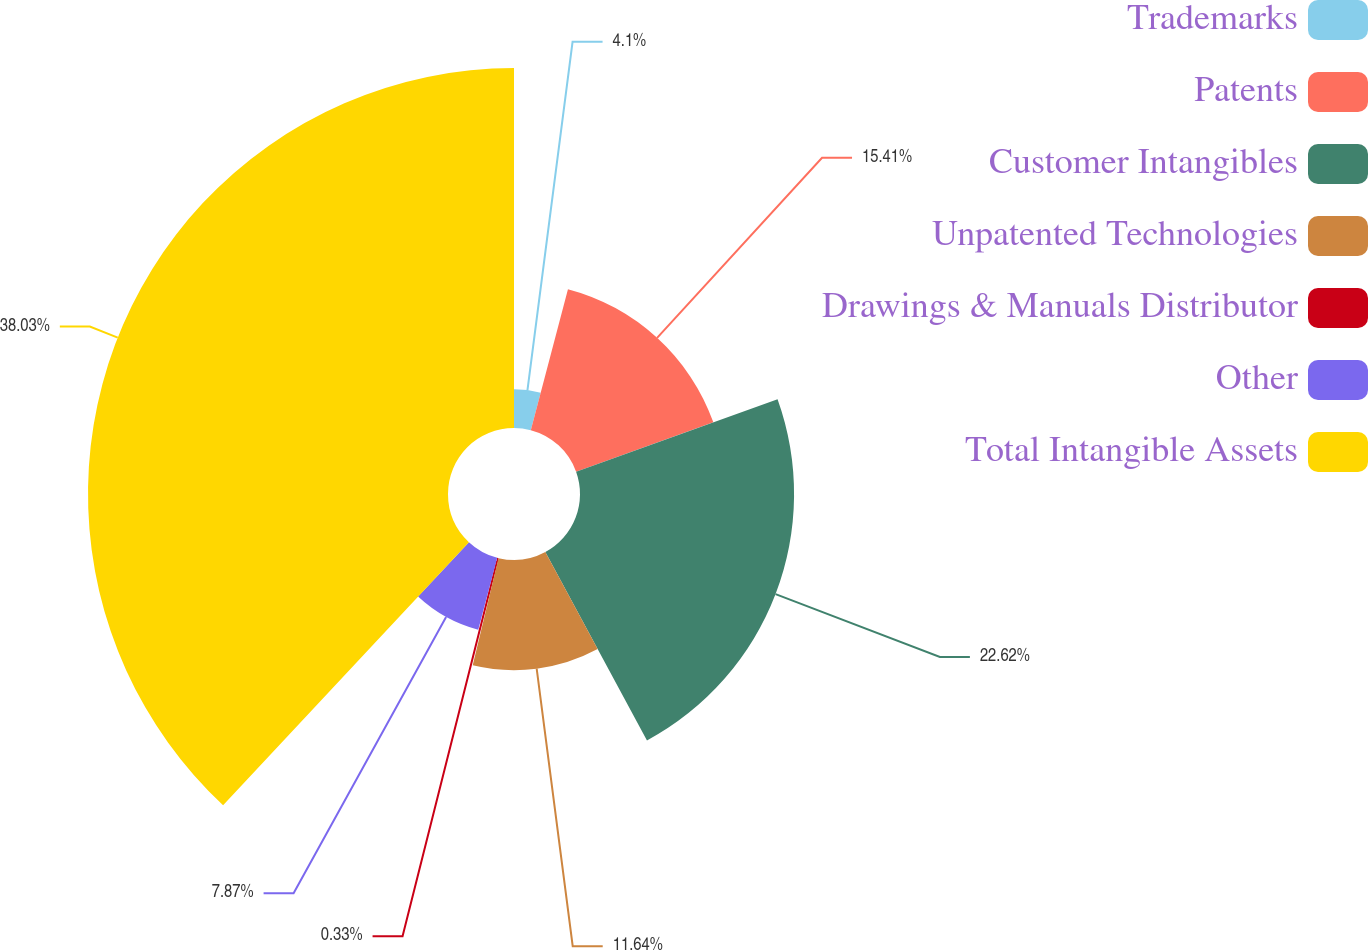Convert chart. <chart><loc_0><loc_0><loc_500><loc_500><pie_chart><fcel>Trademarks<fcel>Patents<fcel>Customer Intangibles<fcel>Unpatented Technologies<fcel>Drawings & Manuals Distributor<fcel>Other<fcel>Total Intangible Assets<nl><fcel>4.1%<fcel>15.41%<fcel>22.62%<fcel>11.64%<fcel>0.33%<fcel>7.87%<fcel>38.04%<nl></chart> 